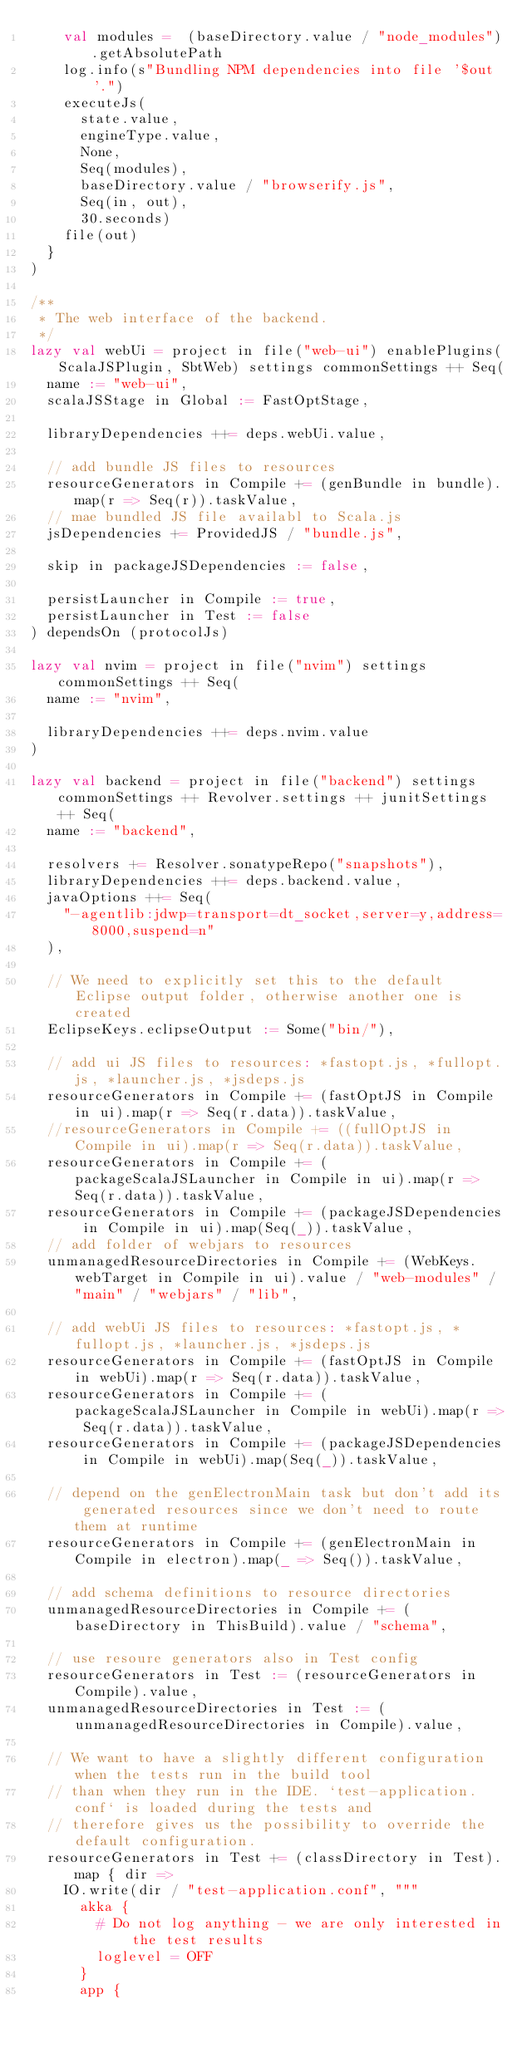<code> <loc_0><loc_0><loc_500><loc_500><_Scala_>    val modules =  (baseDirectory.value / "node_modules").getAbsolutePath
    log.info(s"Bundling NPM dependencies into file '$out'.")
    executeJs(
      state.value,
      engineType.value,
      None,
      Seq(modules),
      baseDirectory.value / "browserify.js",
      Seq(in, out),
      30.seconds)
    file(out)
  }
)

/**
 * The web interface of the backend.
 */
lazy val webUi = project in file("web-ui") enablePlugins(ScalaJSPlugin, SbtWeb) settings commonSettings ++ Seq(
  name := "web-ui",
  scalaJSStage in Global := FastOptStage,

  libraryDependencies ++= deps.webUi.value,

  // add bundle JS files to resources
  resourceGenerators in Compile += (genBundle in bundle).map(r => Seq(r)).taskValue,
  // mae bundled JS file availabl to Scala.js
  jsDependencies += ProvidedJS / "bundle.js",

  skip in packageJSDependencies := false,

  persistLauncher in Compile := true,
  persistLauncher in Test := false
) dependsOn (protocolJs)

lazy val nvim = project in file("nvim") settings commonSettings ++ Seq(
  name := "nvim",

  libraryDependencies ++= deps.nvim.value
)

lazy val backend = project in file("backend") settings commonSettings ++ Revolver.settings ++ junitSettings ++ Seq(
  name := "backend",

  resolvers += Resolver.sonatypeRepo("snapshots"),
  libraryDependencies ++= deps.backend.value,
  javaOptions ++= Seq(
    "-agentlib:jdwp=transport=dt_socket,server=y,address=8000,suspend=n"
  ),

  // We need to explicitly set this to the default Eclipse output folder, otherwise another one is created
  EclipseKeys.eclipseOutput := Some("bin/"),

  // add ui JS files to resources: *fastopt.js, *fullopt.js, *launcher.js, *jsdeps.js
  resourceGenerators in Compile += (fastOptJS in Compile in ui).map(r => Seq(r.data)).taskValue,
  //resourceGenerators in Compile += ((fullOptJS in Compile in ui).map(r => Seq(r.data)).taskValue,
  resourceGenerators in Compile += (packageScalaJSLauncher in Compile in ui).map(r => Seq(r.data)).taskValue,
  resourceGenerators in Compile += (packageJSDependencies in Compile in ui).map(Seq(_)).taskValue,
  // add folder of webjars to resources
  unmanagedResourceDirectories in Compile += (WebKeys.webTarget in Compile in ui).value / "web-modules" / "main" / "webjars" / "lib",

  // add webUi JS files to resources: *fastopt.js, *fullopt.js, *launcher.js, *jsdeps.js
  resourceGenerators in Compile += (fastOptJS in Compile in webUi).map(r => Seq(r.data)).taskValue,
  resourceGenerators in Compile += (packageScalaJSLauncher in Compile in webUi).map(r => Seq(r.data)).taskValue,
  resourceGenerators in Compile += (packageJSDependencies in Compile in webUi).map(Seq(_)).taskValue,

  // depend on the genElectronMain task but don't add its generated resources since we don't need to route them at runtime
  resourceGenerators in Compile += (genElectronMain in Compile in electron).map(_ => Seq()).taskValue,

  // add schema definitions to resource directories
  unmanagedResourceDirectories in Compile += (baseDirectory in ThisBuild).value / "schema",

  // use resoure generators also in Test config
  resourceGenerators in Test := (resourceGenerators in Compile).value,
  unmanagedResourceDirectories in Test := (unmanagedResourceDirectories in Compile).value,

  // We want to have a slightly different configuration when the tests run in the build tool
  // than when they run in the IDE. `test-application.conf` is loaded during the tests and
  // therefore gives us the possibility to override the default configuration.
  resourceGenerators in Test += (classDirectory in Test).map { dir =>
    IO.write(dir / "test-application.conf", """
      akka {
        # Do not log anything - we are only interested in the test results
        loglevel = OFF
      }
      app {</code> 